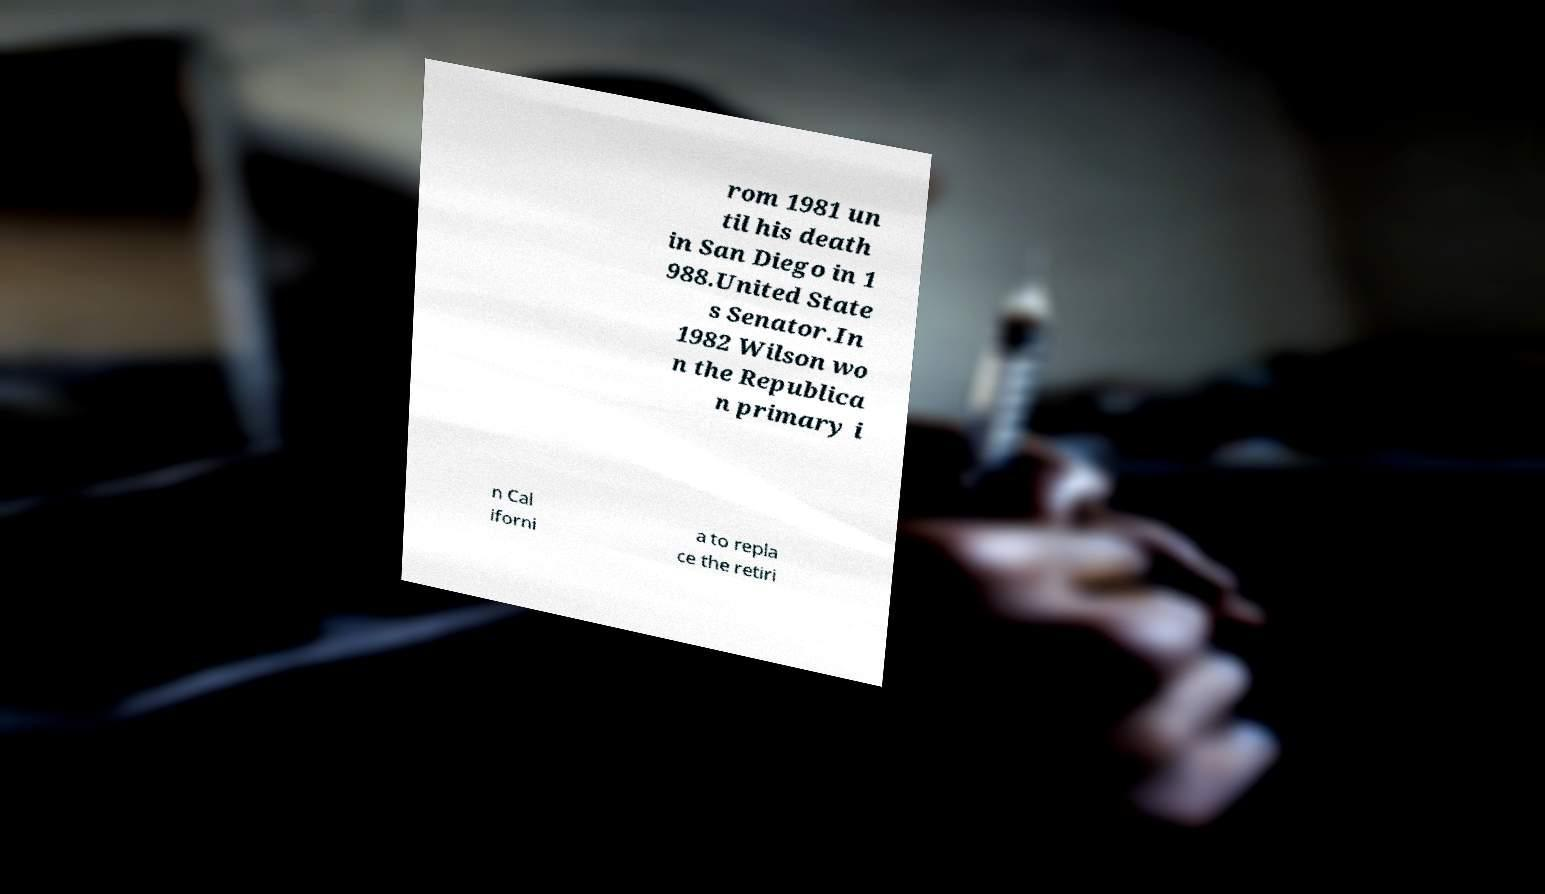There's text embedded in this image that I need extracted. Can you transcribe it verbatim? rom 1981 un til his death in San Diego in 1 988.United State s Senator.In 1982 Wilson wo n the Republica n primary i n Cal iforni a to repla ce the retiri 